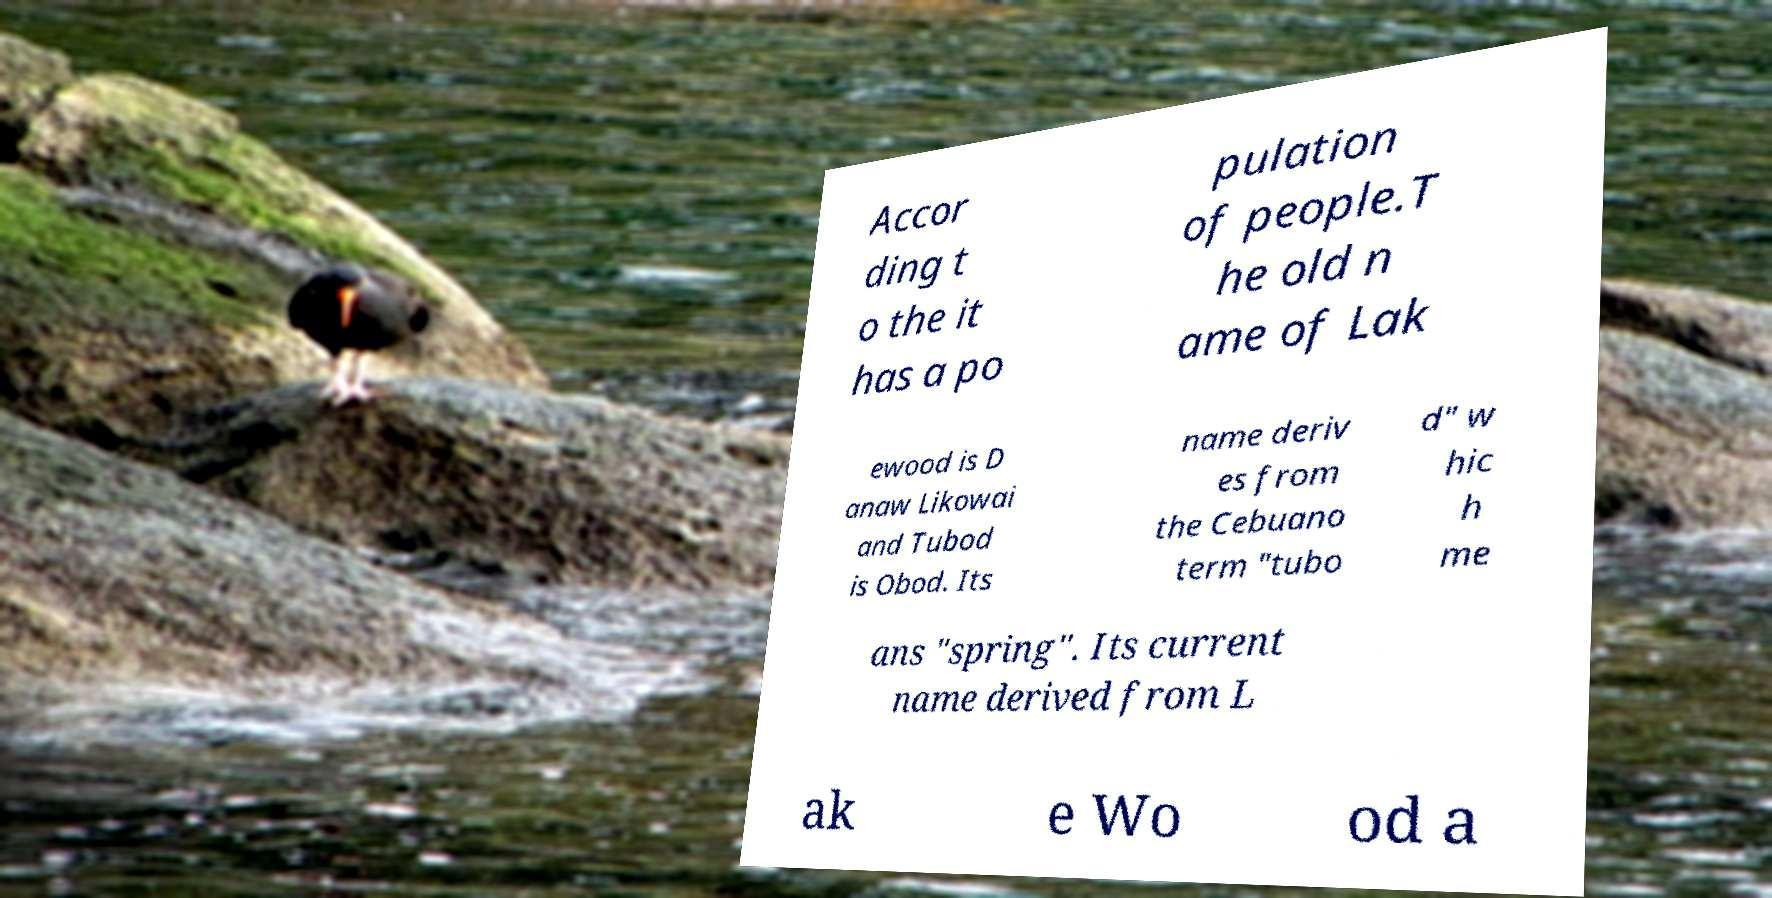Could you assist in decoding the text presented in this image and type it out clearly? Accor ding t o the it has a po pulation of people.T he old n ame of Lak ewood is D anaw Likowai and Tubod is Obod. Its name deriv es from the Cebuano term "tubo d" w hic h me ans "spring". Its current name derived from L ak e Wo od a 